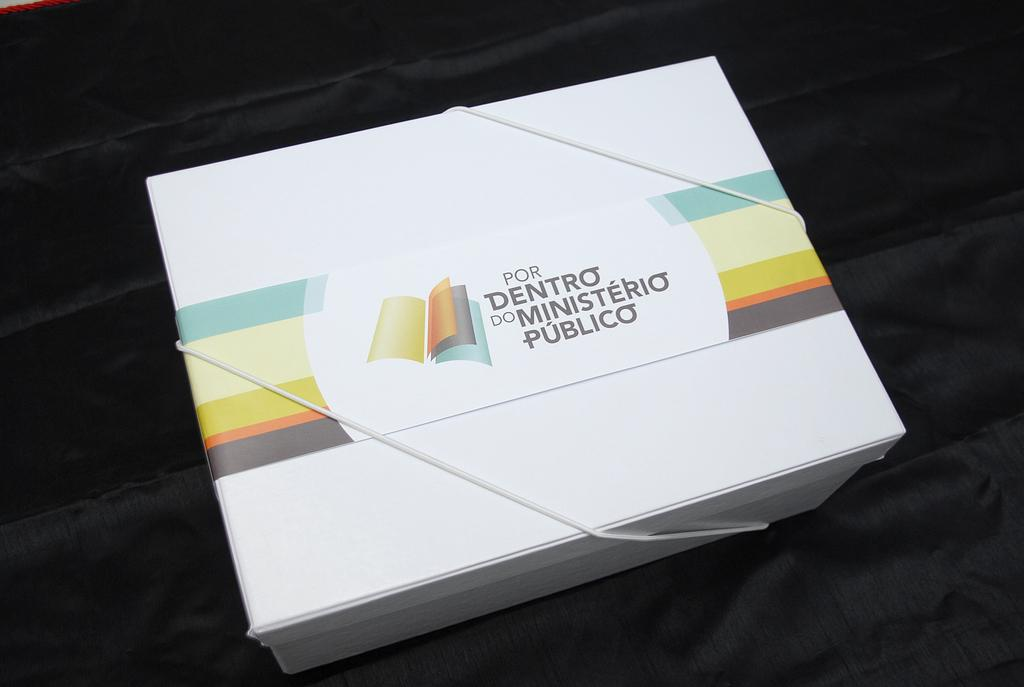<image>
Give a short and clear explanation of the subsequent image. A white box with Por Dentro do Ministeri Publico is written on the lid.. 